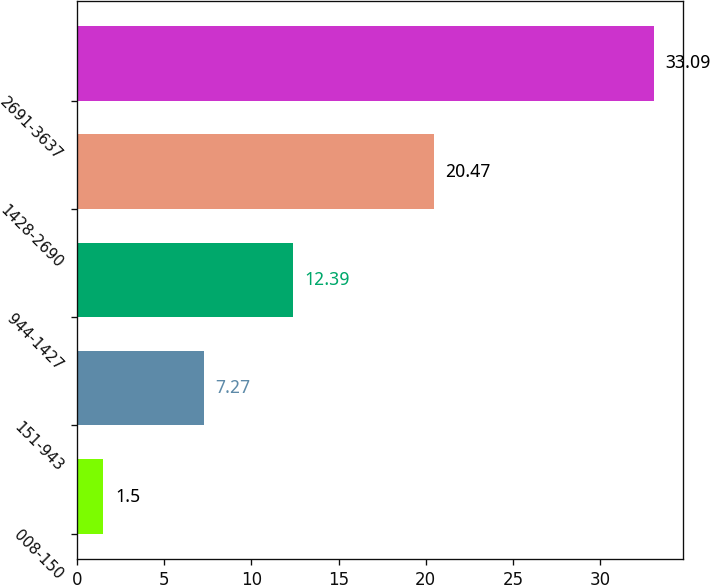<chart> <loc_0><loc_0><loc_500><loc_500><bar_chart><fcel>008-150<fcel>151-943<fcel>944-1427<fcel>1428-2690<fcel>2691-3637<nl><fcel>1.5<fcel>7.27<fcel>12.39<fcel>20.47<fcel>33.09<nl></chart> 